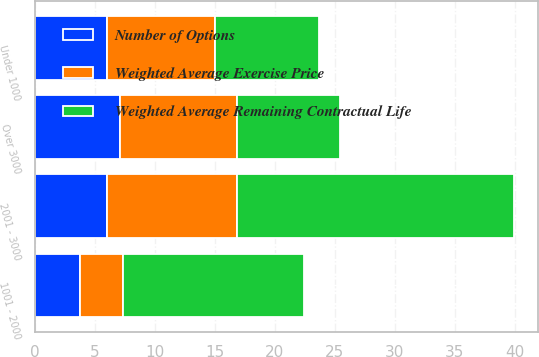Convert chart to OTSL. <chart><loc_0><loc_0><loc_500><loc_500><stacked_bar_chart><ecel><fcel>Under 1000<fcel>1001 - 2000<fcel>2001 - 3000<fcel>Over 3000<nl><fcel>Weighted Average Exercise Price<fcel>9<fcel>3.6<fcel>10.8<fcel>9.7<nl><fcel>Number of Options<fcel>6<fcel>3.7<fcel>6<fcel>7.1<nl><fcel>Weighted Average Remaining Contractual Life<fcel>8.65<fcel>15.14<fcel>23.14<fcel>8.65<nl></chart> 